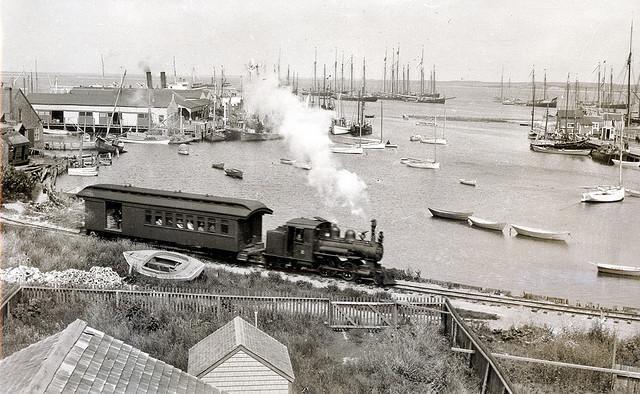How many boats are in the picture?
Give a very brief answer. 1. How many human statues are to the left of the clock face?
Give a very brief answer. 0. 